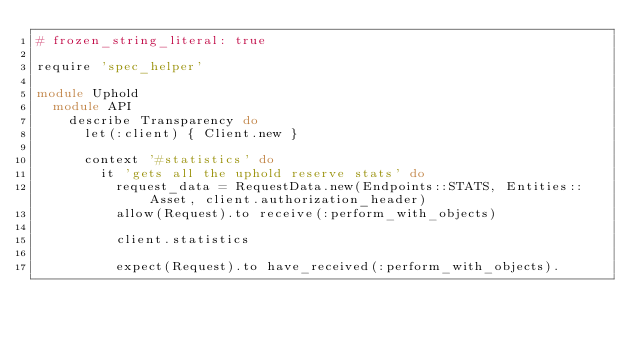Convert code to text. <code><loc_0><loc_0><loc_500><loc_500><_Ruby_># frozen_string_literal: true

require 'spec_helper'

module Uphold
  module API
    describe Transparency do
      let(:client) { Client.new }

      context '#statistics' do
        it 'gets all the uphold reserve stats' do
          request_data = RequestData.new(Endpoints::STATS, Entities::Asset, client.authorization_header)
          allow(Request).to receive(:perform_with_objects)

          client.statistics

          expect(Request).to have_received(:perform_with_objects).</code> 